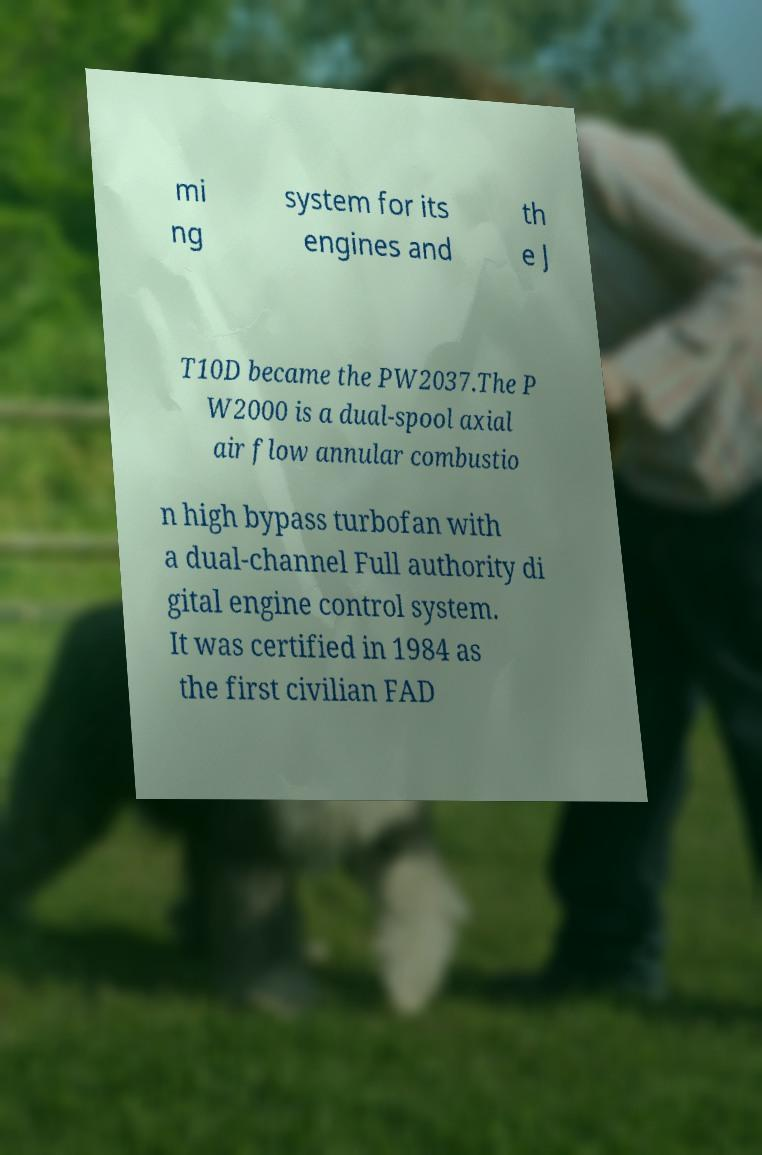Can you read and provide the text displayed in the image?This photo seems to have some interesting text. Can you extract and type it out for me? mi ng system for its engines and th e J T10D became the PW2037.The P W2000 is a dual-spool axial air flow annular combustio n high bypass turbofan with a dual-channel Full authority di gital engine control system. It was certified in 1984 as the first civilian FAD 